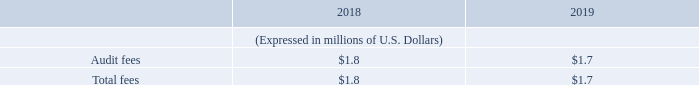ITEM 16.C. PRINCIPAL ACCOUNTANT FEES AND SERVICES
Deloitte LLP, an independent registered public accounting firm, has audited our annual financial statements acting as our independent auditor for the fiscal years ended December 31, 2018 and December 31, 2019.
The chart below sets forth the total amount billed and accrued for Deloitte LLP for services performed in 2018 and 2019, respectively, and breaks down these amounts by the category of service. The fees paid to our principal accountant were approved in accordance with the pre-approval policies and procedures described below.
Audit Fees
Audit fees represent compensation for professional services rendered for the audit of the consolidated financial statements of the Company and the audit of the financial statements for its individual subsidiary companies, fees for the review of the quarterly financial information, as well as in connection with the review of registration statements and related consents and comfort letters, and any other services required for SEC or other regulatory filings
Included in the audit fees for 2018 are fees of $0.2 million related to the Partnership’s public offerings completed in 2018. Included in the audit fees for 2019 are fees of $0.2 million related to equity and bond related transactions.
Tax Fees
No tax fees were billed by our principal accountant in 2018 and 2019.
Audit-Related Fees
No audit-related fees were billed by our principal accountant in 2018 and 2019.
All Other Fees
No other fees were billed by our principal accountant in 2018 and 2019.
What are the components of fees recorded? Audit fees, tax fees, audit-related fees, all other fees. What does audit fees represent? Compensation for professional services rendered for the audit of the consolidated financial statements of the company and the audit of the financial statements for its individual subsidiary companies, fees for the review of the quarterly financial information, as well as in connection with the review of registration statements and related consents and comfort letters, and any other services required for sec or other regulatory filings. How much are the fees related to equity and bond related transactions in 2019? $0.2 million. In which year was the audit fees lower? $1.7 < $1.8
Answer: 2019. What was the change in audit fees from 2018 to 2019?
Answer scale should be: million. $1.7 - $1.8 
Answer: -0.1. What was the percentage change in total fees from 2018 to 2019?
Answer scale should be: percent. ($1.7 - $1.8)/$1.8 
Answer: -5.56. 